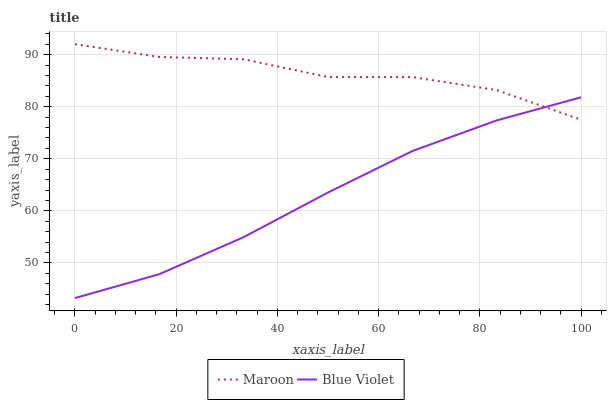Does Blue Violet have the minimum area under the curve?
Answer yes or no. Yes. Does Maroon have the maximum area under the curve?
Answer yes or no. Yes. Does Maroon have the minimum area under the curve?
Answer yes or no. No. Is Blue Violet the smoothest?
Answer yes or no. Yes. Is Maroon the roughest?
Answer yes or no. Yes. Is Maroon the smoothest?
Answer yes or no. No. Does Blue Violet have the lowest value?
Answer yes or no. Yes. Does Maroon have the lowest value?
Answer yes or no. No. Does Maroon have the highest value?
Answer yes or no. Yes. Does Maroon intersect Blue Violet?
Answer yes or no. Yes. Is Maroon less than Blue Violet?
Answer yes or no. No. Is Maroon greater than Blue Violet?
Answer yes or no. No. 